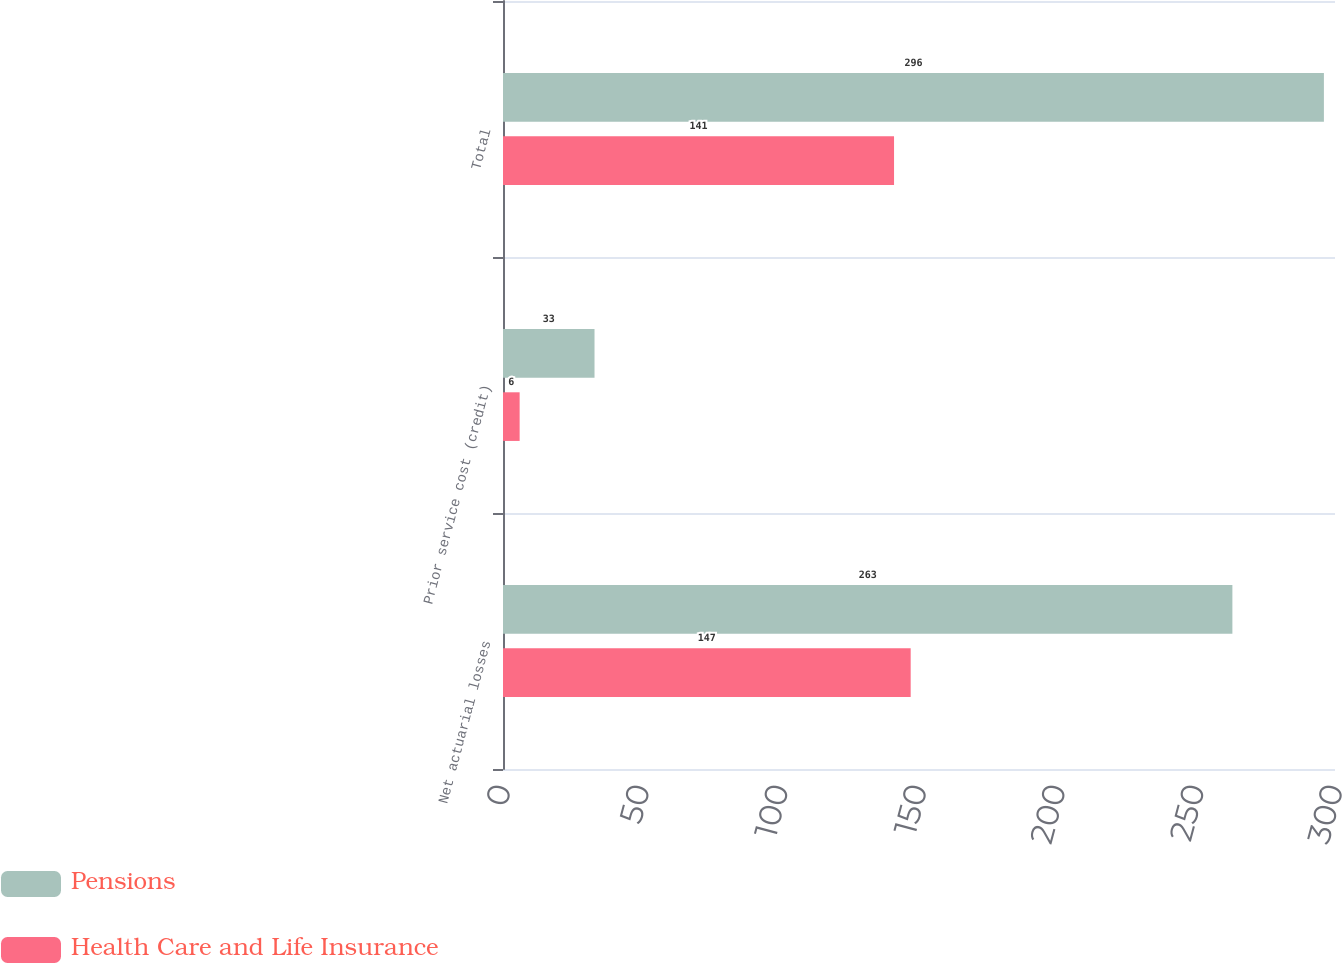Convert chart to OTSL. <chart><loc_0><loc_0><loc_500><loc_500><stacked_bar_chart><ecel><fcel>Net actuarial losses<fcel>Prior service cost (credit)<fcel>Total<nl><fcel>Pensions<fcel>263<fcel>33<fcel>296<nl><fcel>Health Care and Life Insurance<fcel>147<fcel>6<fcel>141<nl></chart> 